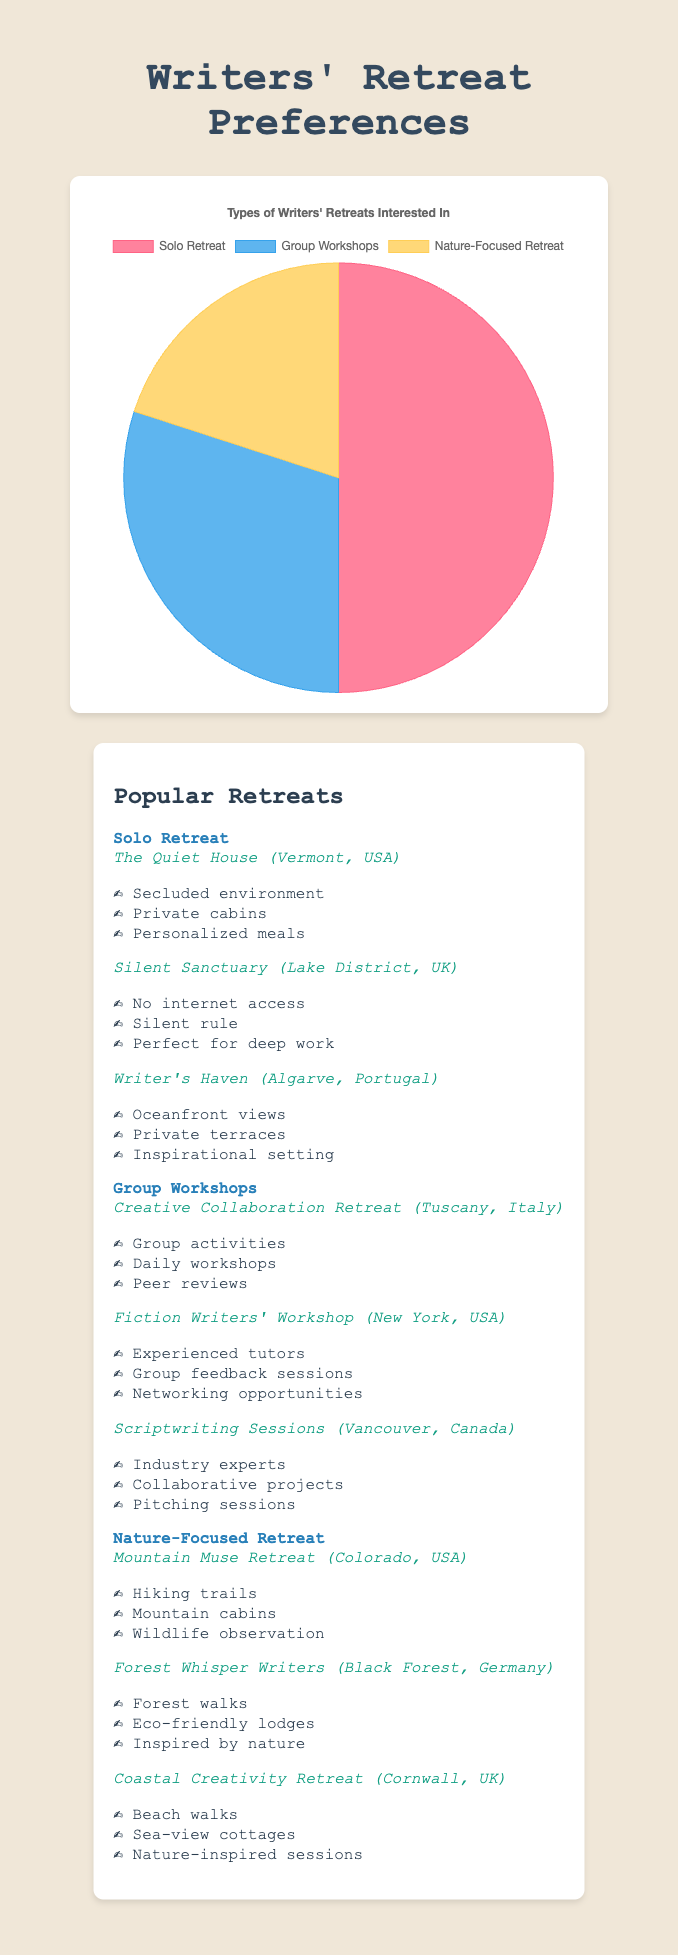What is the most popular type of writers' retreat? The pie chart shows three types of retreats: Solo Retreat, Group Workshops, and Nature-Focused Retreat. The segment representing Solo Retreat is the largest.
Answer: Solo Retreat Which type of writers' retreat has the least participants? By looking at the pie chart, the smallest segment belongs to Nature-Focused Retreat.
Answer: Nature-Focused Retreat How many more participants are interested in Solo Retreats compared to Group Workshops? Solo Retreat has 50 participants and Group Workshops have 30 participants. The difference is 50 - 30 = 20.
Answer: 20 What fraction of the total participants prefer Nature-Focused Retreats? The total number of participants is 50 (Solo) + 30 (Group Workshops) + 20 (Nature-Focused) = 100. The fraction for Nature-Focused is 20/100 = 1/5.
Answer: 1/5 Which two types of retreats combined account for the majority of the participants? Adding participants for Solo Retreat (50) and Group Workshops (30) gives 50 + 30 = 80, which is greater than half of the total participants (100).
Answer: Solo Retreat and Group Workshops If you need peace and quiet for concentrated writing, which retreat type would you likely prefer based on the visuals? By examining the highlighted features in the retreat information, Solo Retreats offer secluded environments and silence, ideal for concentrated writing.
Answer: Solo Retreat What percentage of participants prefer Group Workshops? Group Workshops have 30 participants out of a total of 100 participants. The percentage is (30/100) * 100% = 30%.
Answer: 30% Among the types of retreats, which one has participants that likely prefer collaborative and interactive sessions? According to the highlighted features listed, Group Workshops emphasize group activities and peer reviews, indicating a preference for collaborative and interactive sessions.
Answer: Group Workshops How many more participants prefer Solo Retreats than Nature-Focused Retreats? Solo Retreats have 50 participants and Nature-Focused Retreats have 20 participants. The difference is 50 - 20 = 30.
Answer: 30 What color represents Nature-Focused Retreat on the chart? By looking at the chart's legend, the segment for Nature-Focused Retreat is colored yellow.
Answer: Yellow 